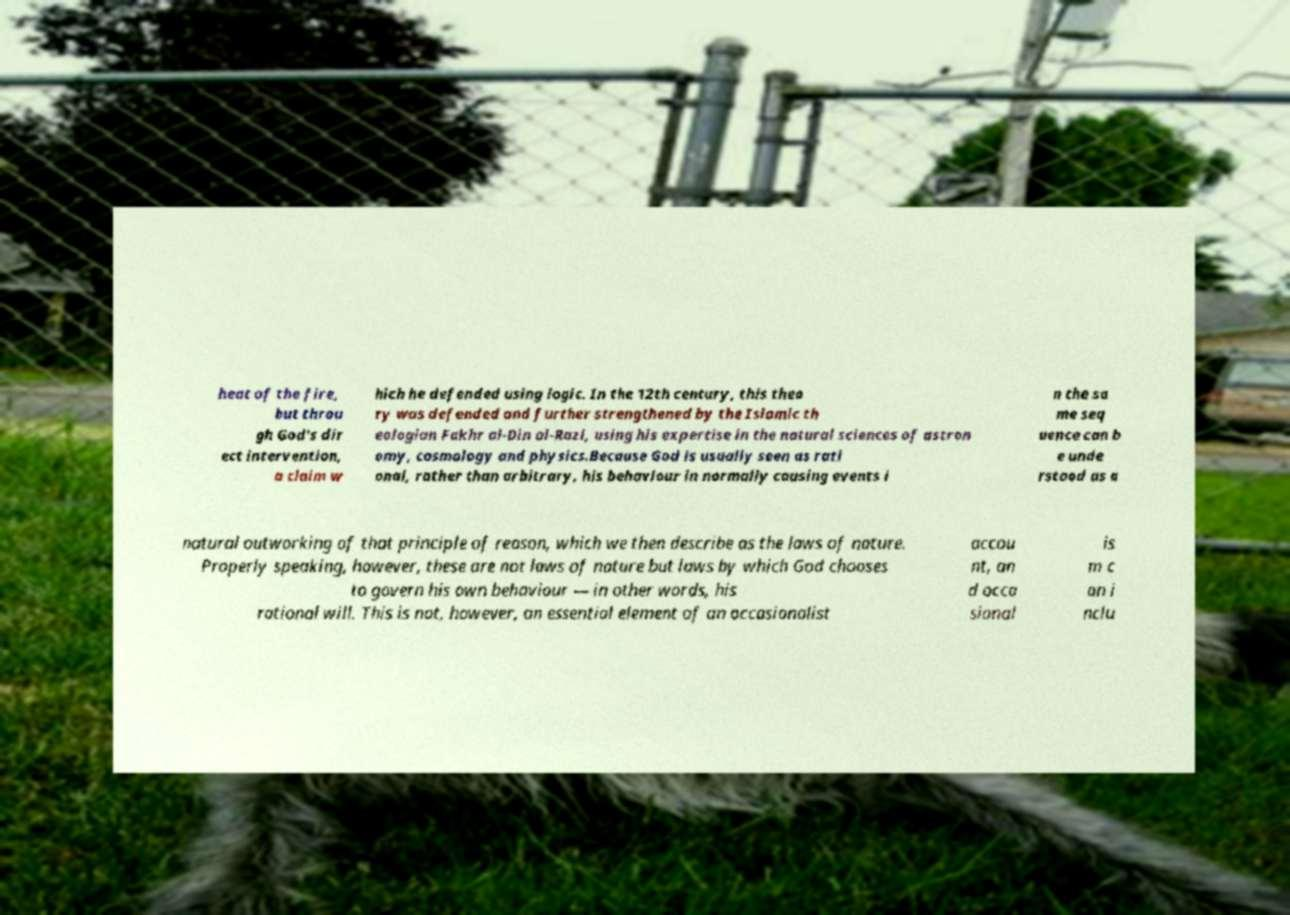Could you extract and type out the text from this image? heat of the fire, but throu gh God's dir ect intervention, a claim w hich he defended using logic. In the 12th century, this theo ry was defended and further strengthened by the Islamic th eologian Fakhr al-Din al-Razi, using his expertise in the natural sciences of astron omy, cosmology and physics.Because God is usually seen as rati onal, rather than arbitrary, his behaviour in normally causing events i n the sa me seq uence can b e unde rstood as a natural outworking of that principle of reason, which we then describe as the laws of nature. Properly speaking, however, these are not laws of nature but laws by which God chooses to govern his own behaviour — in other words, his rational will. This is not, however, an essential element of an occasionalist accou nt, an d occa sional is m c an i nclu 